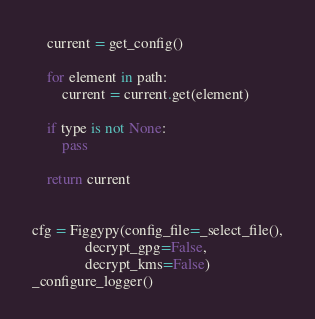<code> <loc_0><loc_0><loc_500><loc_500><_Python_>    current = get_config()

    for element in path:
        current = current.get(element)

    if type is not None:
        pass

    return current


cfg = Figgypy(config_file=_select_file(),
              decrypt_gpg=False,
              decrypt_kms=False)
_configure_logger()


</code> 